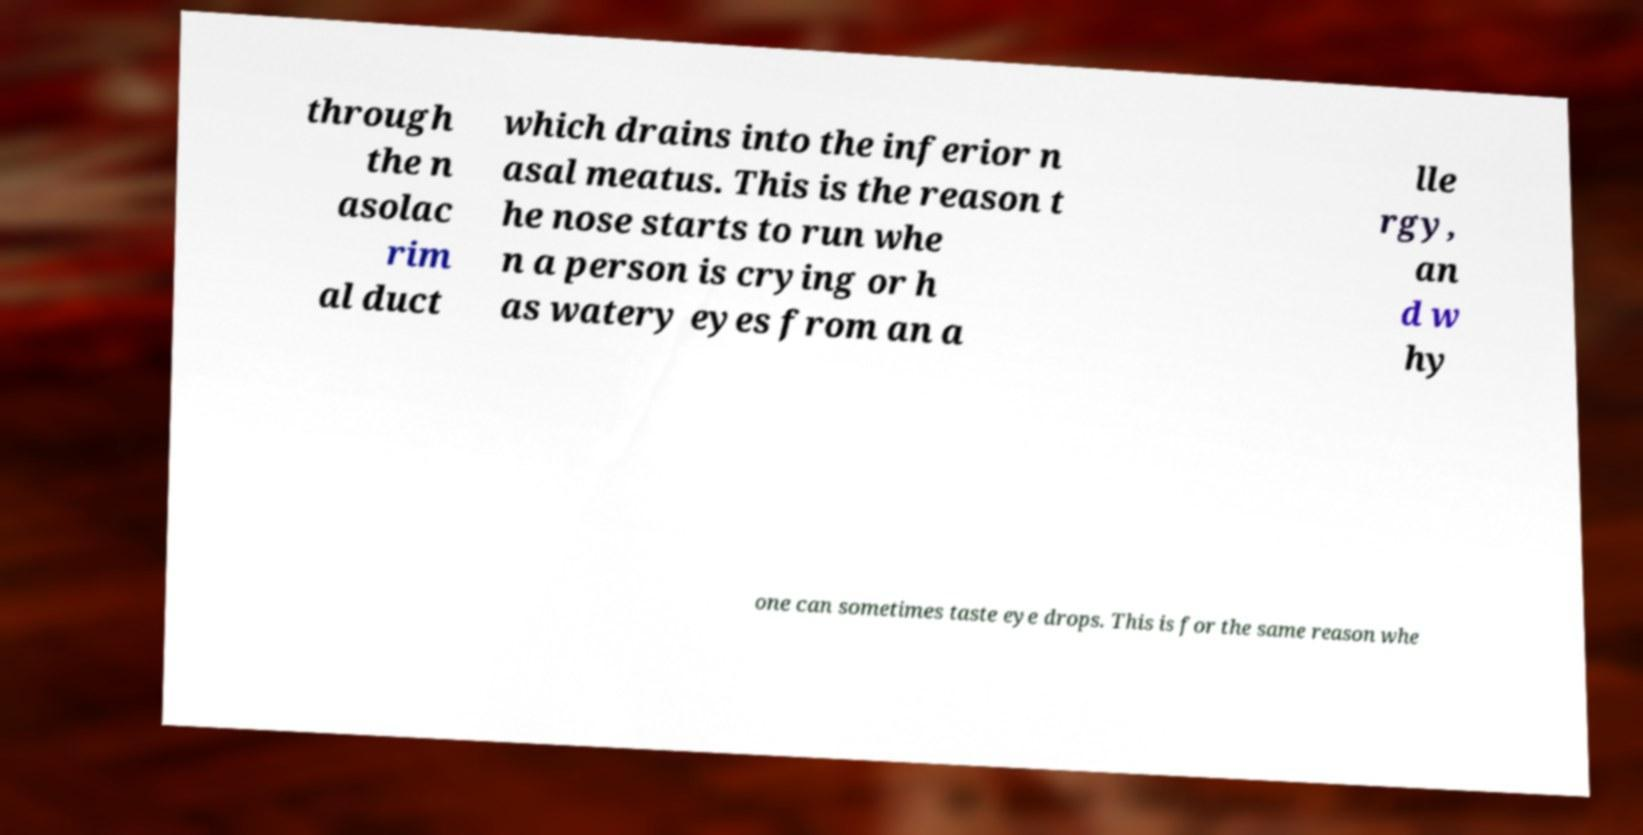For documentation purposes, I need the text within this image transcribed. Could you provide that? through the n asolac rim al duct which drains into the inferior n asal meatus. This is the reason t he nose starts to run whe n a person is crying or h as watery eyes from an a lle rgy, an d w hy one can sometimes taste eye drops. This is for the same reason whe 